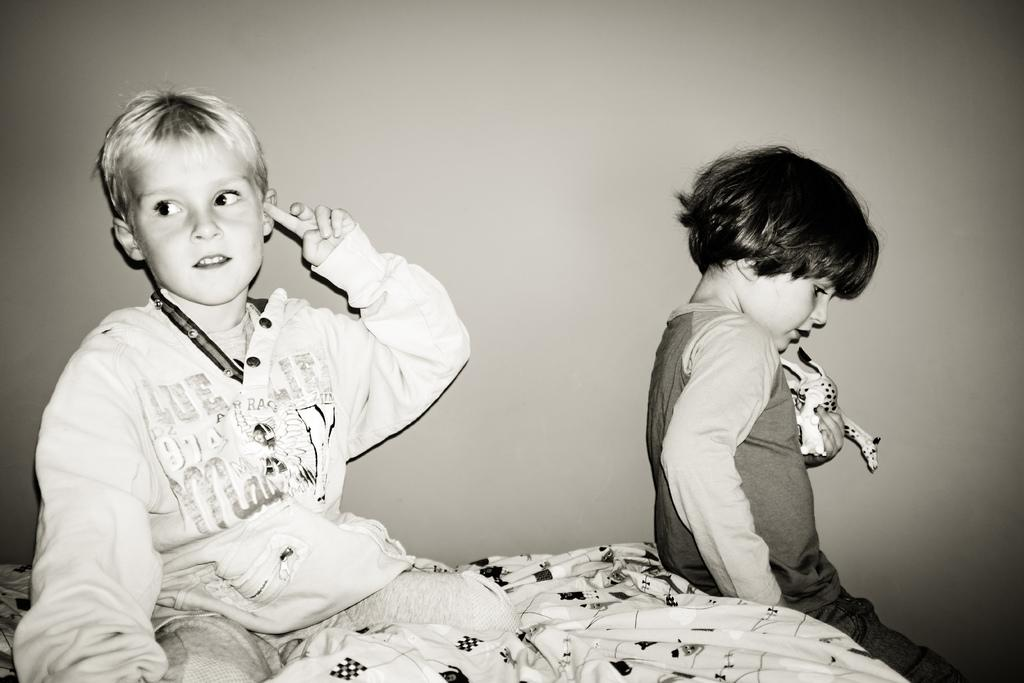How many children are present in the image? There are two children in the image. What are the children doing in the image? The children are sitting. Can you describe what one of the children is holding? One child is holding an unspecified thing. What can be seen in the background of the image? There is a wall in the background of the image. What is the color scheme of the image? The image is in black and white. What type of drug is the child holding in the image? There is no drug present in the image; one child is holding an unspecified thing. How does the actor in the image interact with the wall? There is no actor present in the image, and the children are not interacting with the wall. 